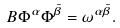Convert formula to latex. <formula><loc_0><loc_0><loc_500><loc_500>\L B { \Phi ^ { \alpha } } { \Phi ^ { \bar { \beta } } } = \omega ^ { \alpha \bar { \beta } } .</formula> 